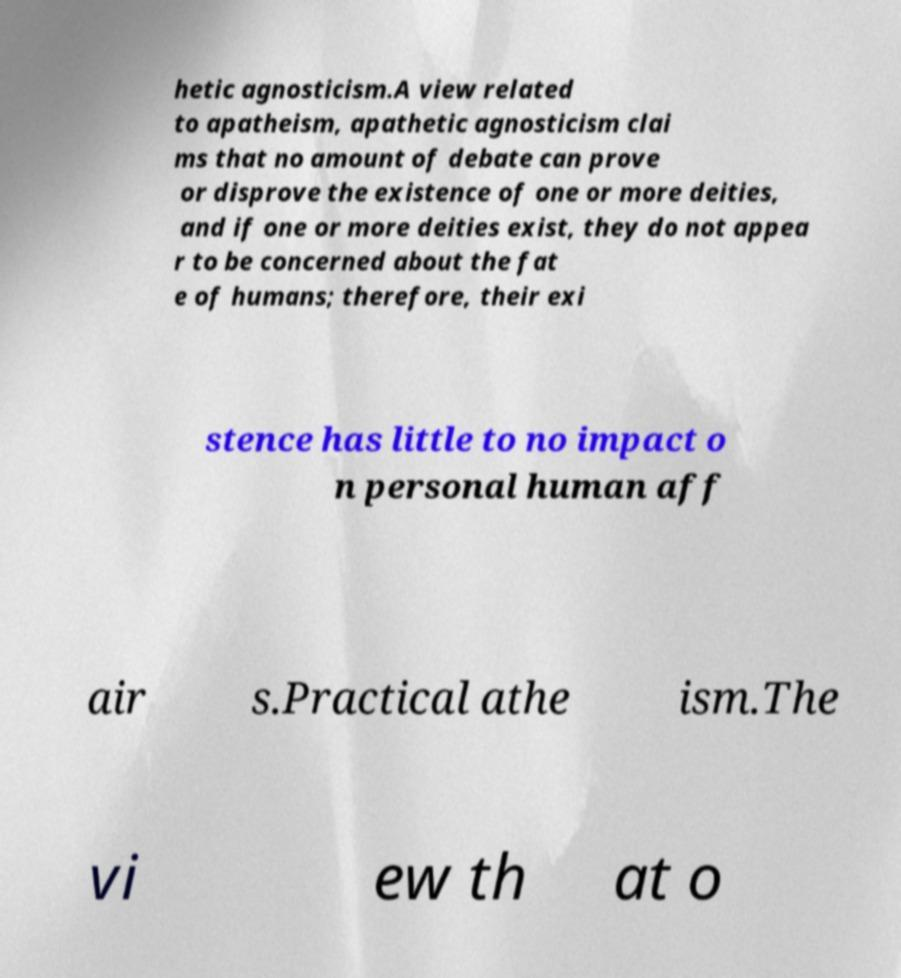Could you assist in decoding the text presented in this image and type it out clearly? hetic agnosticism.A view related to apatheism, apathetic agnosticism clai ms that no amount of debate can prove or disprove the existence of one or more deities, and if one or more deities exist, they do not appea r to be concerned about the fat e of humans; therefore, their exi stence has little to no impact o n personal human aff air s.Practical athe ism.The vi ew th at o 